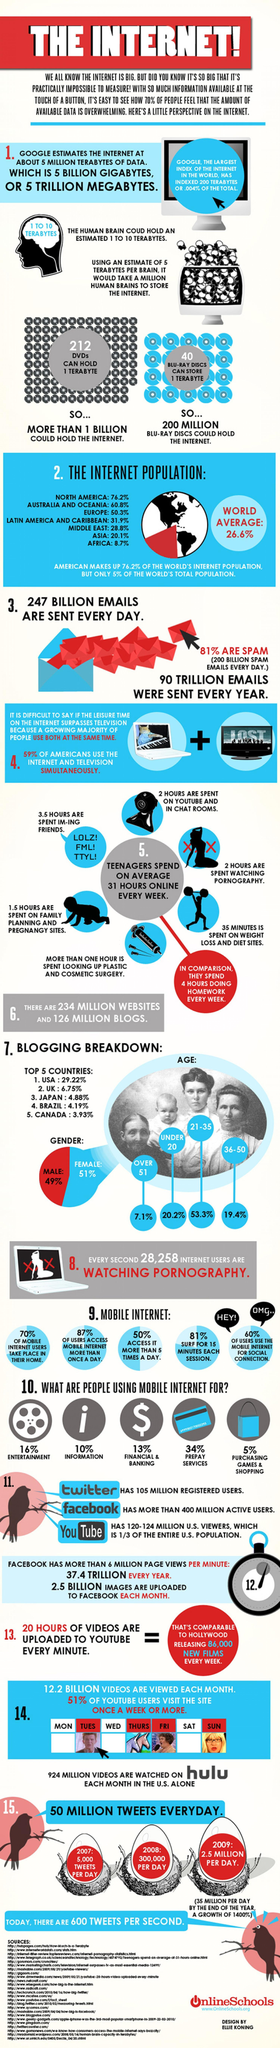How many tweets are made per day in 2009?
Answer the question with a short phrase. 2.5 MILLION What percentage of bloggers are females? 51% What percentage of bloggers are aged between 21-35? 53.3% How many tweets are made per day in 2008? 300,000 Which age group people are less interested in blogging? OVER 51 What percentage of users use the mobile internet for social connection? 60% What is the percentage of the internet population in Europe? 50.3% What percentage of bloggers are aged between 36-50? 19.4% What percentage of bloggers are males? 49% What is the percentage of bloggers in the UK? 6.75% 